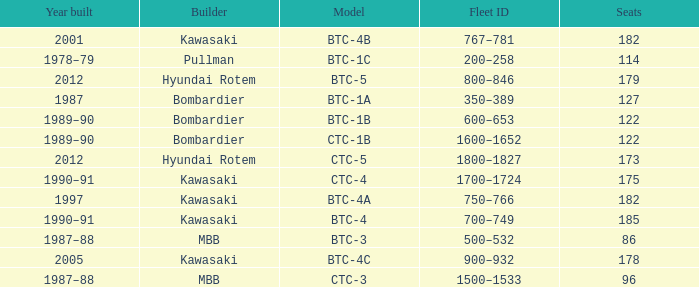Which model has 175 seats? CTC-4. 